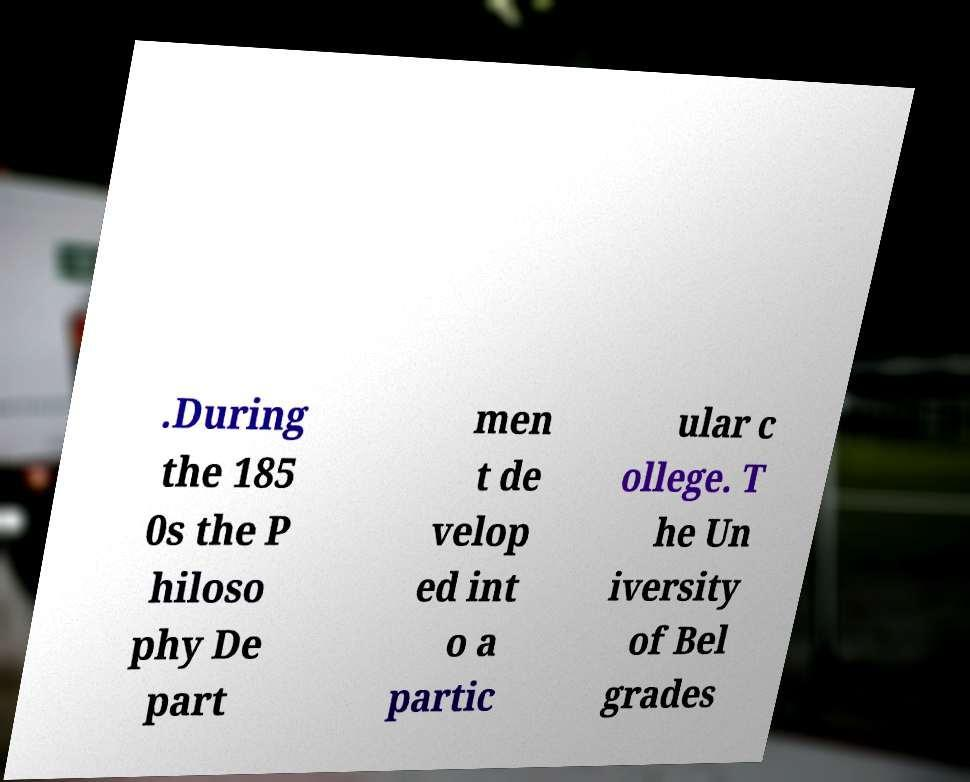Please read and relay the text visible in this image. What does it say? .During the 185 0s the P hiloso phy De part men t de velop ed int o a partic ular c ollege. T he Un iversity of Bel grades 